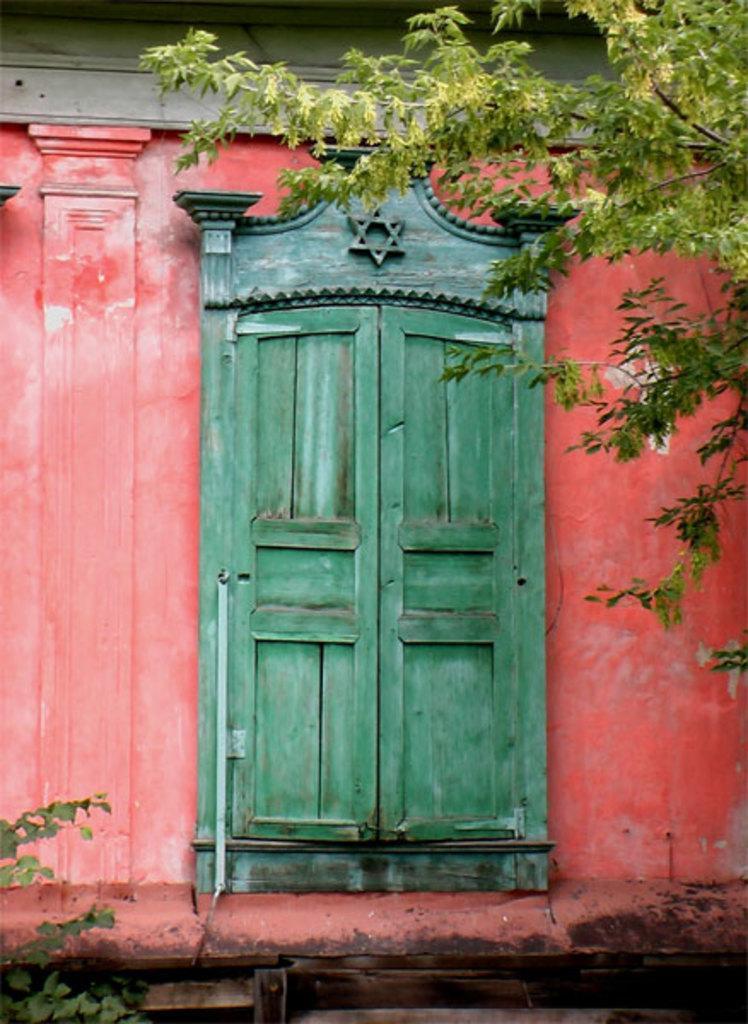In one or two sentences, can you explain what this image depicts? In this image I can see the wall with a door. There is a tree and there is a plant. 